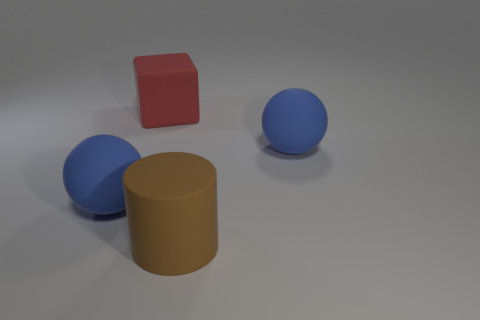What color is the big cylinder that is the same material as the red cube?
Provide a short and direct response. Brown. What number of brown things are made of the same material as the large cylinder?
Ensure brevity in your answer.  0. There is a big brown matte object; how many large matte balls are on the right side of it?
Offer a terse response. 1. Is the material of the blue sphere that is on the right side of the brown matte cylinder the same as the ball on the left side of the brown matte thing?
Offer a terse response. Yes. Is the number of brown cylinders that are on the right side of the cube greater than the number of big brown rubber things behind the brown matte cylinder?
Your answer should be compact. Yes. Is there anything else that is the same shape as the red object?
Offer a terse response. No. There is a thing that is both behind the brown cylinder and to the right of the cube; what material is it made of?
Keep it short and to the point. Rubber. Are the big red block and the sphere to the right of the big brown object made of the same material?
Offer a very short reply. Yes. Is there anything else that is the same size as the cube?
Your answer should be very brief. Yes. What number of objects are large red cubes or matte things behind the big cylinder?
Provide a short and direct response. 3. 